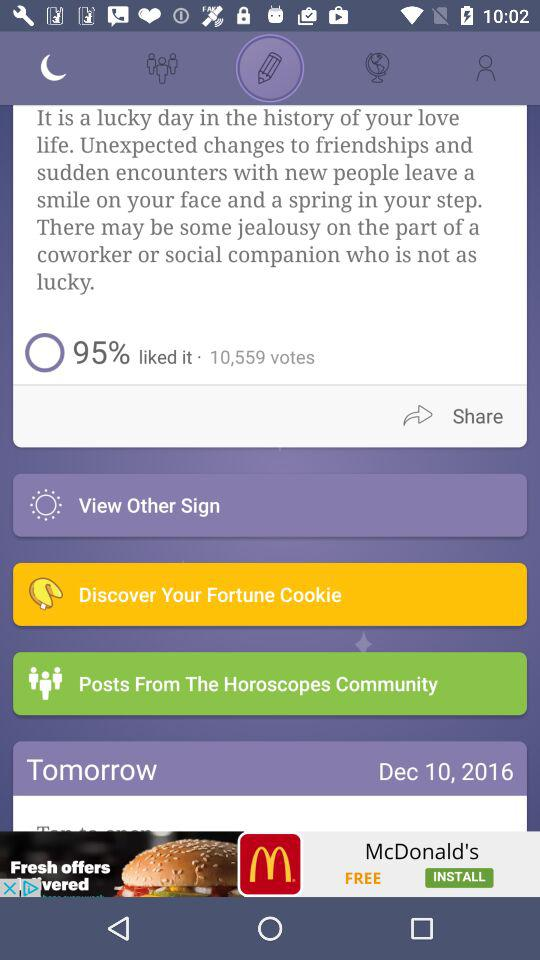What is the mentioned date? The mentioned date is December 10, 2016. 